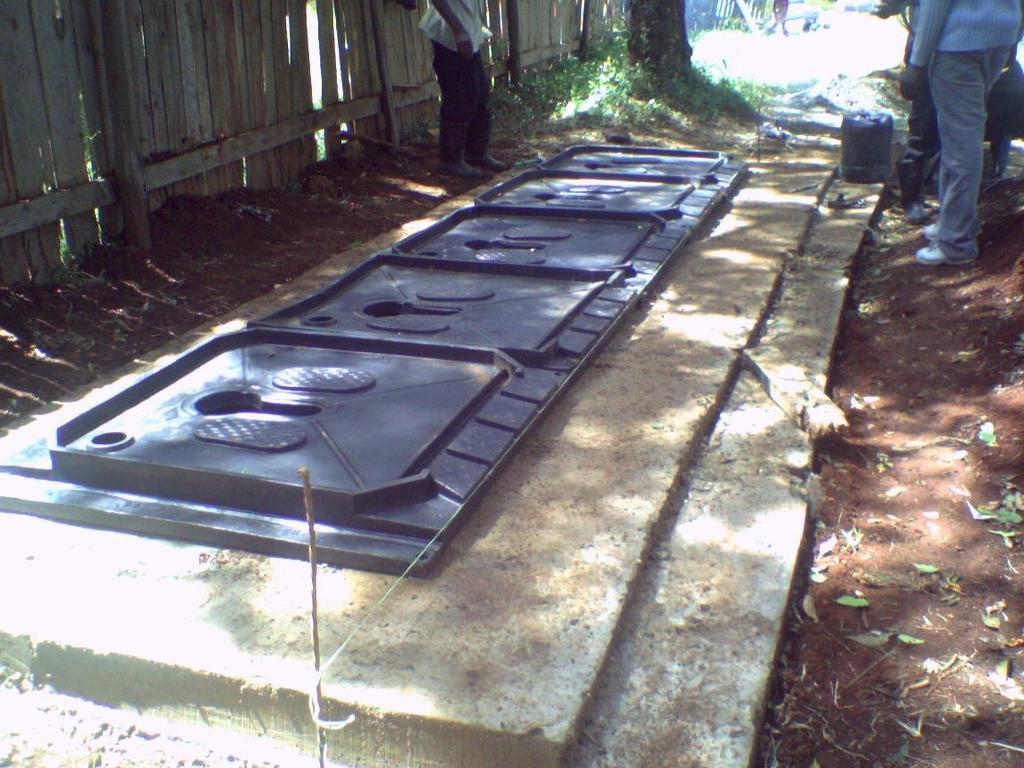Can you describe this image briefly? In this picture I can see two persons who are standing near to the steel gate which is on the floor. On the left I can see the wooden partition. At the top I can see the sky, trees, plants and grass. 